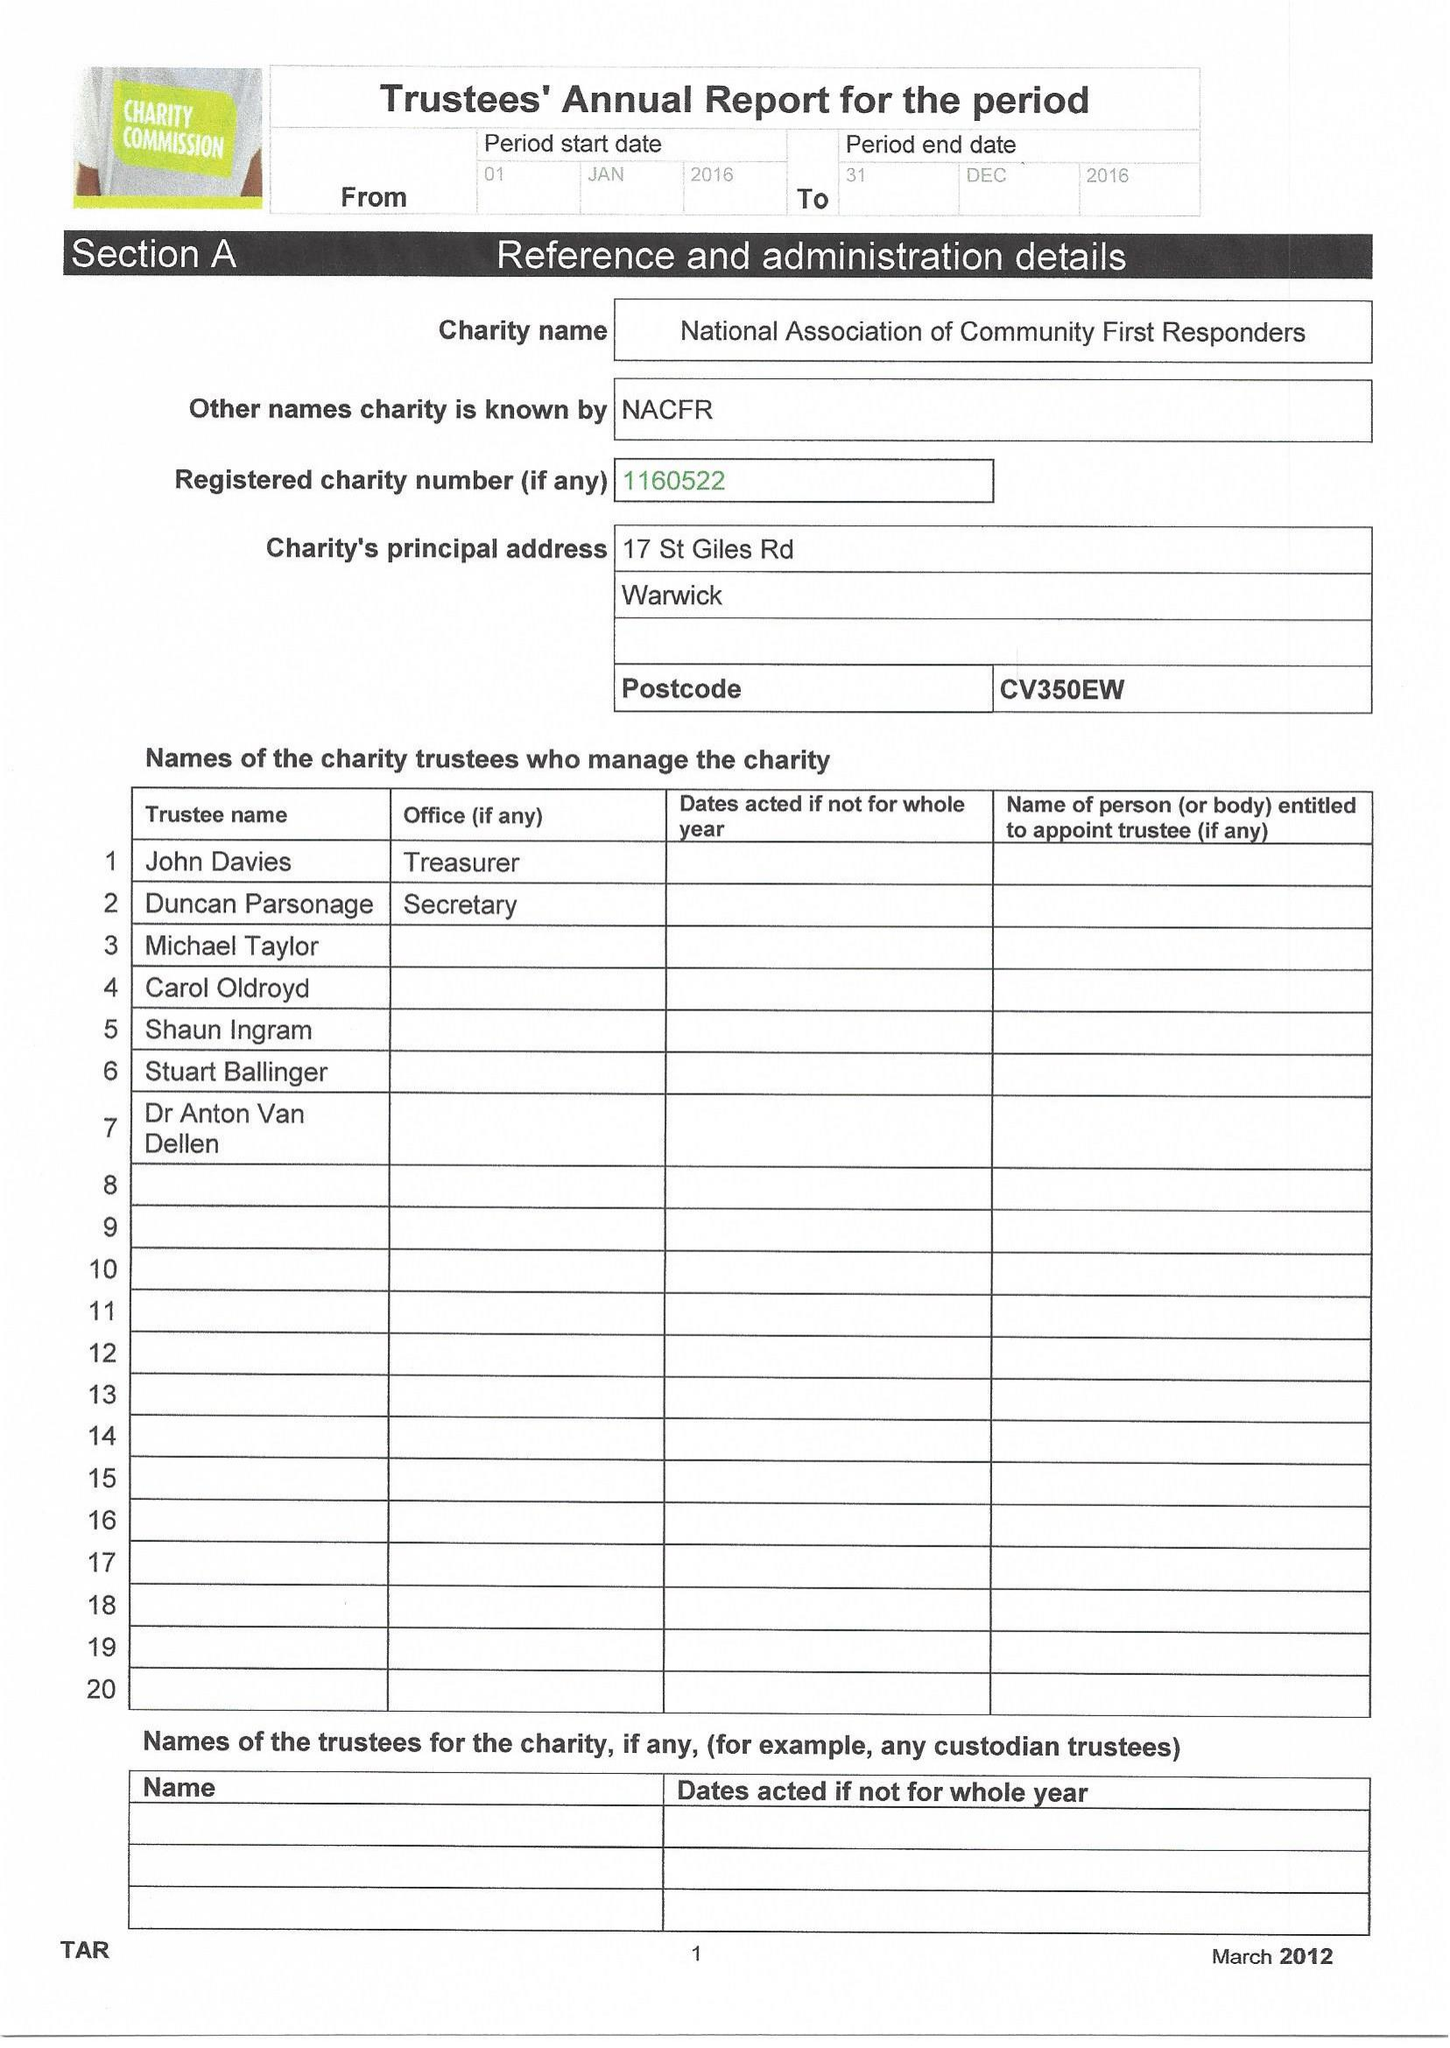What is the value for the charity_name?
Answer the question using a single word or phrase. National Association Of Community First Responders 